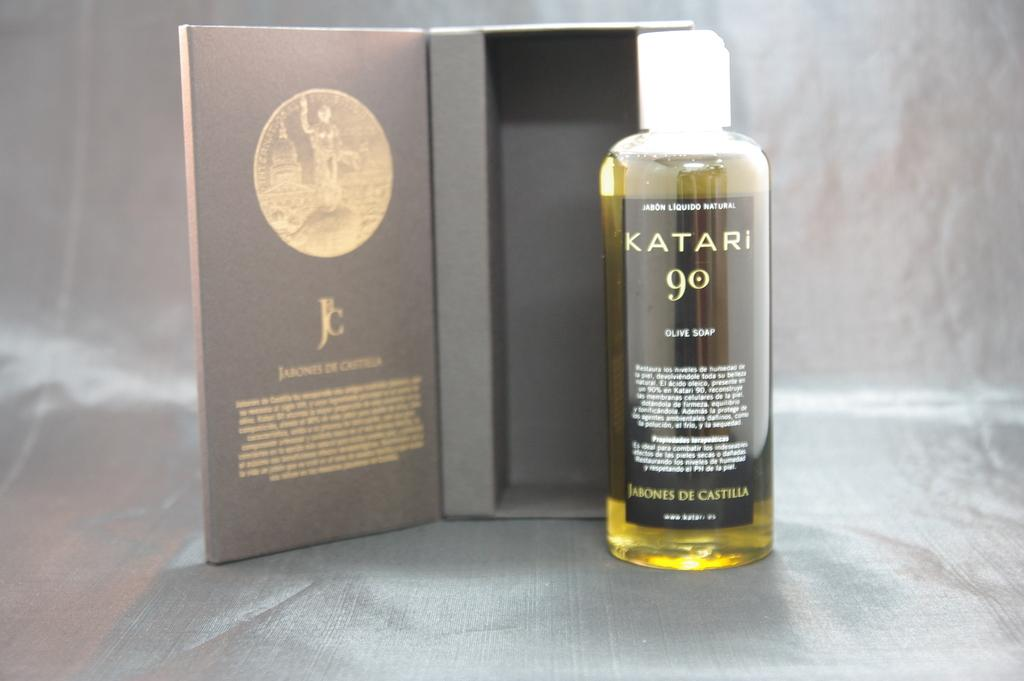<image>
Share a concise interpretation of the image provided. A box with a bottle of Katari 90 sitting in front of it. 